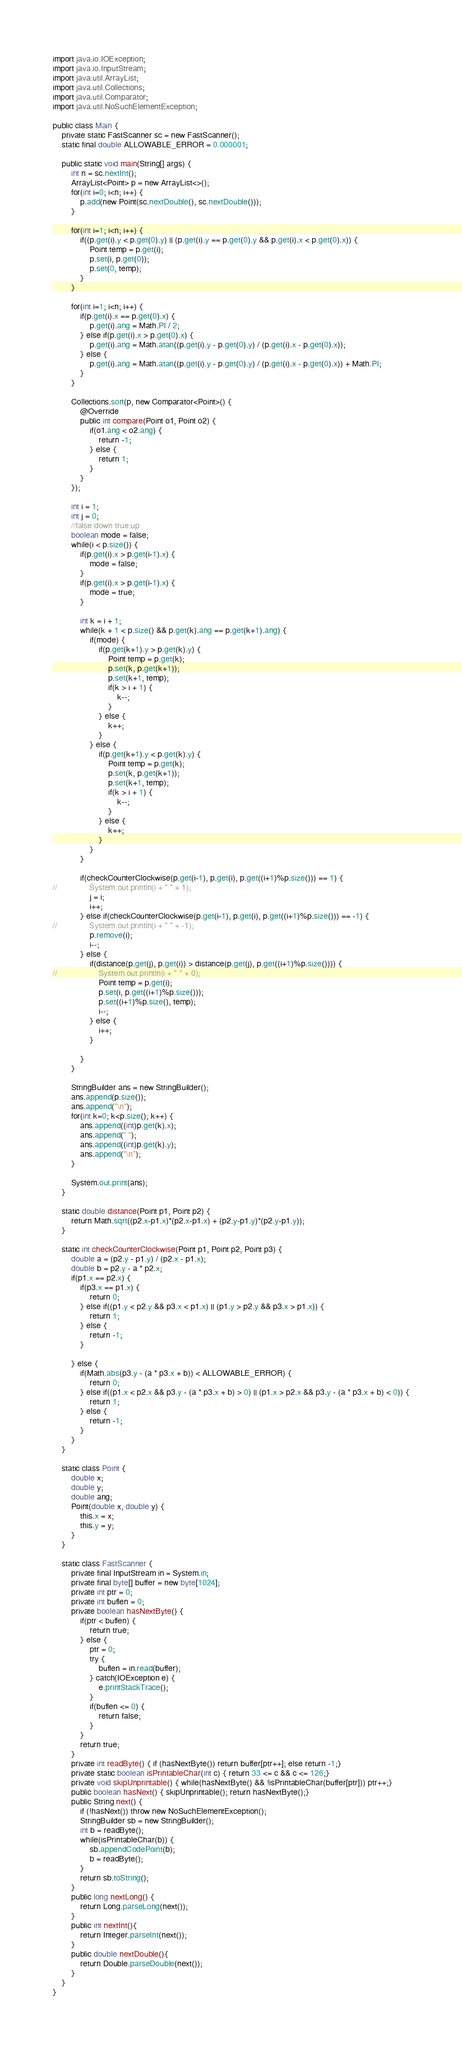Convert code to text. <code><loc_0><loc_0><loc_500><loc_500><_Java_>import java.io.IOException;
import java.io.InputStream;
import java.util.ArrayList;
import java.util.Collections;
import java.util.Comparator;
import java.util.NoSuchElementException;

public class Main {
	private static FastScanner sc = new FastScanner();
	static final double ALLOWABLE_ERROR = 0.000001;

	public static void main(String[] args) {
		int n = sc.nextInt();
		ArrayList<Point> p = new ArrayList<>();
		for(int i=0; i<n; i++) {
			p.add(new Point(sc.nextDouble(), sc.nextDouble()));
		}
		
		for(int i=1; i<n; i++) {
			if((p.get(i).y < p.get(0).y) || (p.get(i).y == p.get(0).y && p.get(i).x < p.get(0).x)) {
				Point temp = p.get(i);
				p.set(i, p.get(0));
				p.set(0, temp);
			}
		}
		
		for(int i=1; i<n; i++) {
			if(p.get(i).x == p.get(0).x) {
				p.get(i).ang = Math.PI / 2;
			} else if(p.get(i).x > p.get(0).x) {
				p.get(i).ang = Math.atan((p.get(i).y - p.get(0).y) / (p.get(i).x - p.get(0).x));
			} else {
				p.get(i).ang = Math.atan((p.get(i).y - p.get(0).y) / (p.get(i).x - p.get(0).x)) + Math.PI;
			}
		}
		
		Collections.sort(p, new Comparator<Point>() {
			@Override
			public int compare(Point o1, Point o2) {
				if(o1.ang < o2.ang) {
					return -1;
				} else {
					return 1;
				}
			}
		});
		
		int i = 1;
		int j = 0;
		//false:down true:up
		boolean mode = false;
		while(i < p.size()) {
			if(p.get(i).x > p.get(i-1).x) {
				mode = false;
			}
			if(p.get(i).x > p.get(i-1).x) {
				mode = true;
			}
			
			int k = i + 1;
			while(k + 1 < p.size() && p.get(k).ang == p.get(k+1).ang) {
				if(mode) {
					if(p.get(k+1).y > p.get(k).y) {
						Point temp = p.get(k);
						p.set(k, p.get(k+1));
						p.set(k+1, temp);
						if(k > i + 1) {
							k--;
						}
					} else {
						k++;
					}
				} else {
					if(p.get(k+1).y < p.get(k).y) {
						Point temp = p.get(k);
						p.set(k, p.get(k+1));
						p.set(k+1, temp);
						if(k > i + 1) {
							k--;
						}
					} else {
						k++;
					}
				}
			}
			
			if(checkCounterClockwise(p.get(i-1), p.get(i), p.get((i+1)%p.size())) == 1) {
//				System.out.println(i + " " + 1);
				j = i;
				i++;
			} else if(checkCounterClockwise(p.get(i-1), p.get(i), p.get((i+1)%p.size())) == -1) {
//				System.out.println(i + " " + -1);
				p.remove(i);
				i--;
			} else {
				if(distance(p.get(j), p.get(i)) > distance(p.get(j), p.get((i+1)%p.size()))) {
//					System.out.println(i + " " + 0);
					Point temp = p.get(i);
					p.set(i, p.get((i+1)%p.size()));
					p.set((i+1)%p.size(), temp);
					i--;
				} else {
					i++;
				}
				
			}
		}
		
		StringBuilder ans = new StringBuilder();
		ans.append(p.size());
		ans.append("\n");
		for(int k=0; k<p.size(); k++) {
			ans.append((int)p.get(k).x);
			ans.append(" ");
			ans.append((int)p.get(k).y);
			ans.append("\n");
		}
		
		System.out.print(ans);
	}
	
	static double distance(Point p1, Point p2) {
		return Math.sqrt((p2.x-p1.x)*(p2.x-p1.x) + (p2.y-p1.y)*(p2.y-p1.y));
	}
	
	static int checkCounterClockwise(Point p1, Point p2, Point p3) {
		double a = (p2.y - p1.y) / (p2.x - p1.x);
		double b = p2.y - a * p2.x;
		if(p1.x == p2.x) {
			if(p3.x == p1.x) {
				return 0;
			} else if((p1.y < p2.y && p3.x < p1.x) || (p1.y > p2.y && p3.x > p1.x)) {
				return 1;
			} else {
				return -1;
			}	
			
		} else {
			if(Math.abs(p3.y - (a * p3.x + b)) < ALLOWABLE_ERROR) {
				return 0;
			} else if((p1.x < p2.x && p3.y - (a * p3.x + b) > 0) || (p1.x > p2.x && p3.y - (a * p3.x + b) < 0)) {
				return 1;
			} else {
				return -1;
			}				
		}
	}

	static class Point {
		double x;
		double y;
		double ang;
		Point(double x, double y) {
			this.x = x;
			this.y = y;
		}
	}
	
	static class FastScanner {
        private final InputStream in = System.in;
        private final byte[] buffer = new byte[1024];
        private int ptr = 0;
        private int buflen = 0;
        private boolean hasNextByte() {
            if(ptr < buflen) {
                return true;
            } else {
                ptr = 0;
                try {
                    buflen = in.read(buffer);
                } catch(IOException e) {
                    e.printStackTrace();
                }
                if(buflen <= 0) {
                    return false;
                }
            }
            return true;
        }
        private int readByte() { if (hasNextByte()) return buffer[ptr++]; else return -1;}
        private static boolean isPrintableChar(int c) { return 33 <= c && c <= 126;}
        private void skipUnprintable() { while(hasNextByte() && !isPrintableChar(buffer[ptr])) ptr++;}
        public boolean hasNext() { skipUnprintable(); return hasNextByte();}
        public String next() {
            if (!hasNext()) throw new NoSuchElementException();
            StringBuilder sb = new StringBuilder();
            int b = readByte();
            while(isPrintableChar(b)) {
                sb.appendCodePoint(b);
                b = readByte();
            }
            return sb.toString();
        }
        public long nextLong() {
            return Long.parseLong(next());
        }
        public int nextInt(){
            return Integer.parseInt(next());
        }
        public double nextDouble(){
            return Double.parseDouble(next());
        }
    }
}</code> 